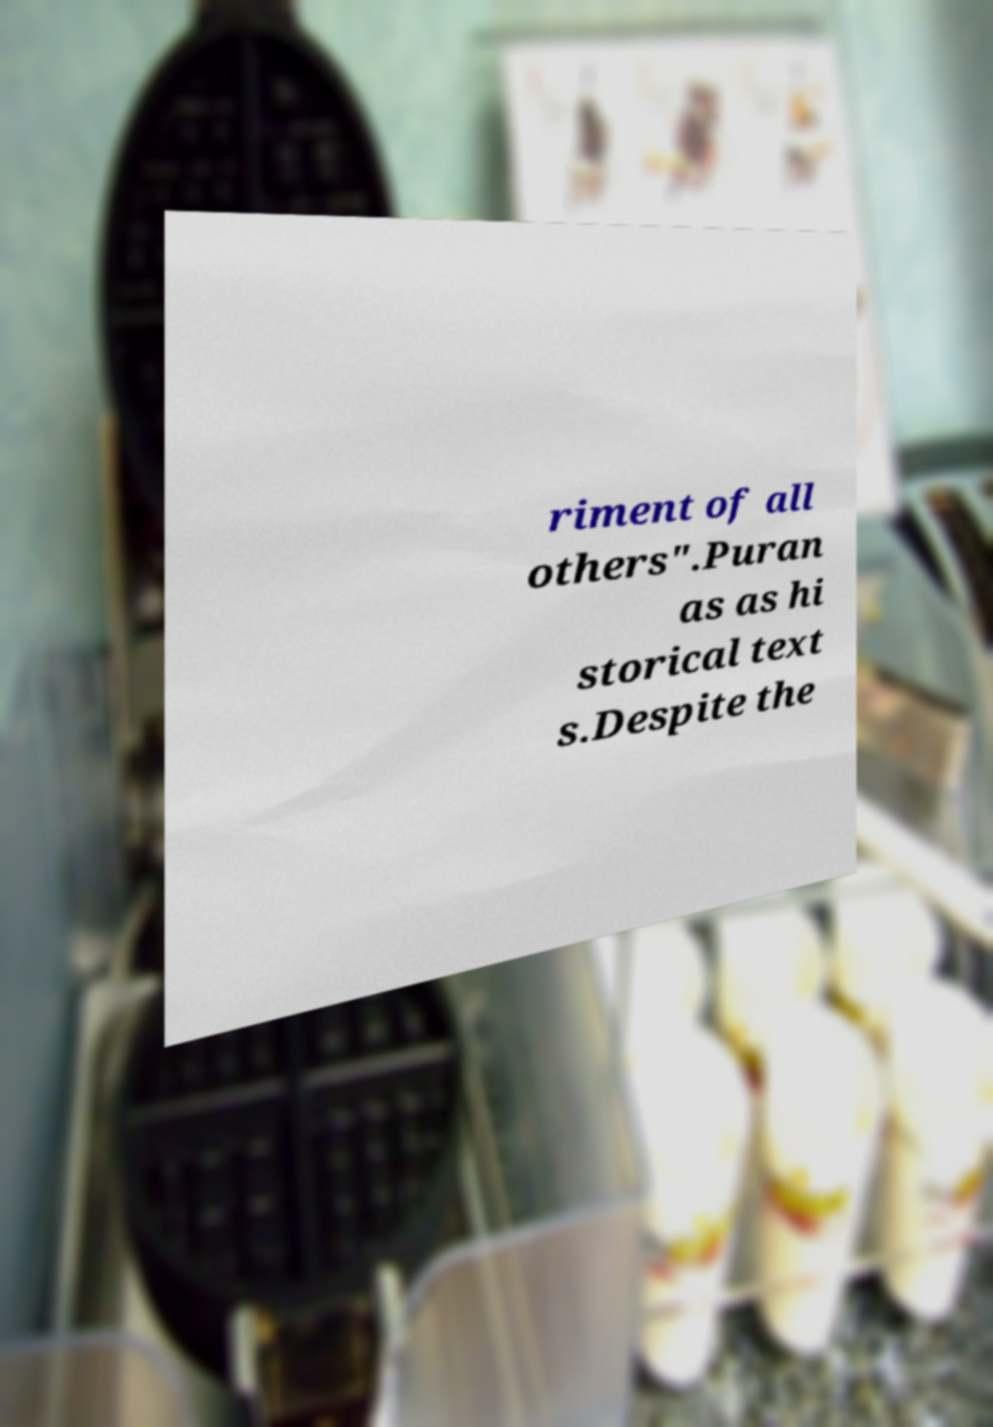What messages or text are displayed in this image? I need them in a readable, typed format. riment of all others".Puran as as hi storical text s.Despite the 